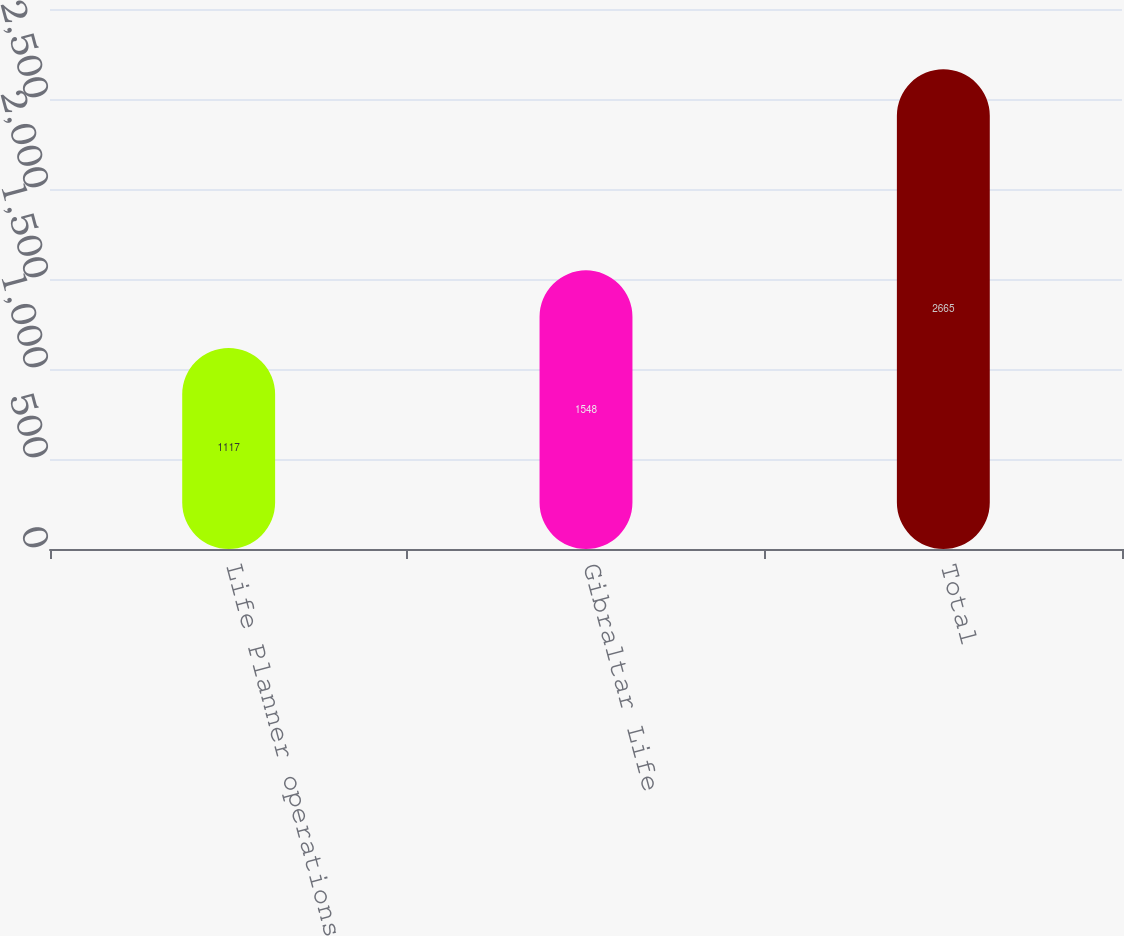Convert chart to OTSL. <chart><loc_0><loc_0><loc_500><loc_500><bar_chart><fcel>Life Planner operations<fcel>Gibraltar Life<fcel>Total<nl><fcel>1117<fcel>1548<fcel>2665<nl></chart> 